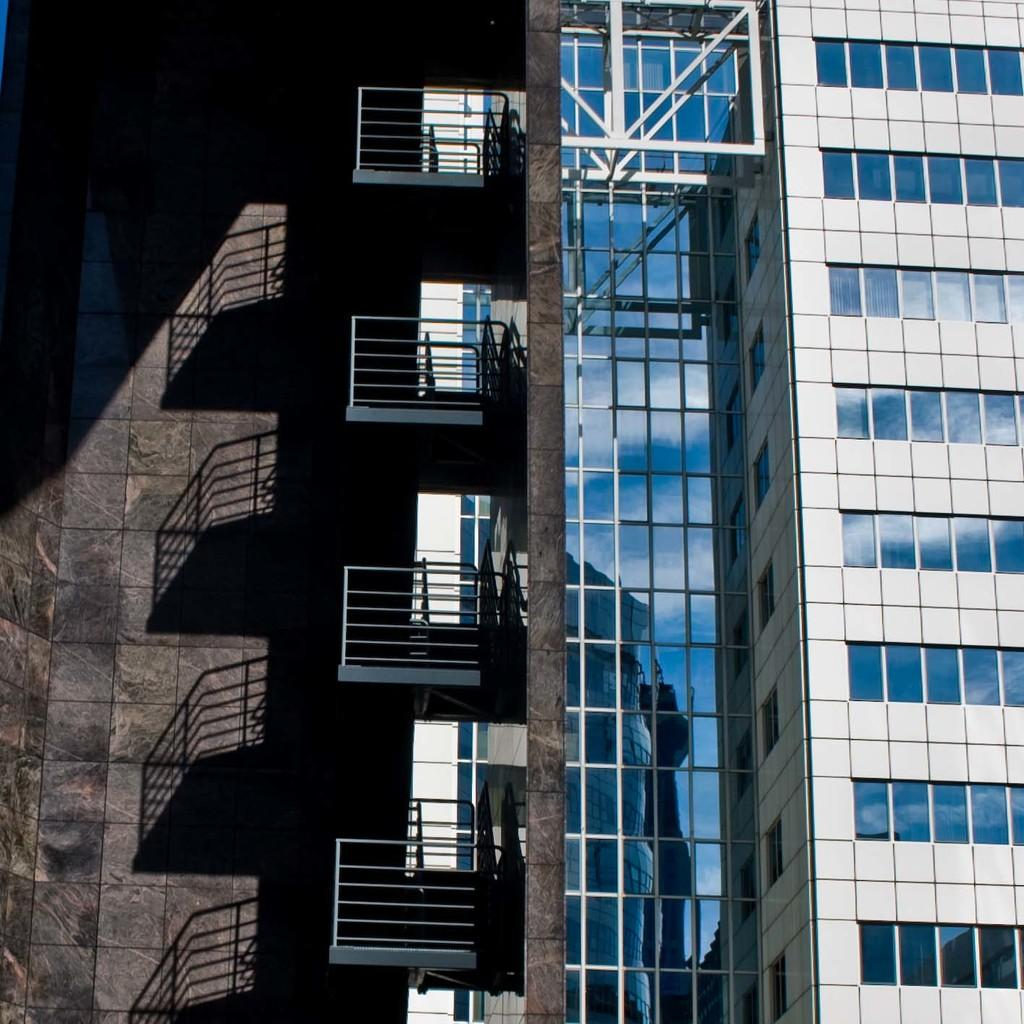What type of structure is visible in the image? There is a building in the image. What colors are used to paint the building? The building is colored blue and white. What is located on the left side of the image? There is a wall on the left side of the image. How does the oatmeal contribute to the heating of the building in the image? There is no oatmeal present in the image, and therefore it cannot contribute to the heating of the building. 